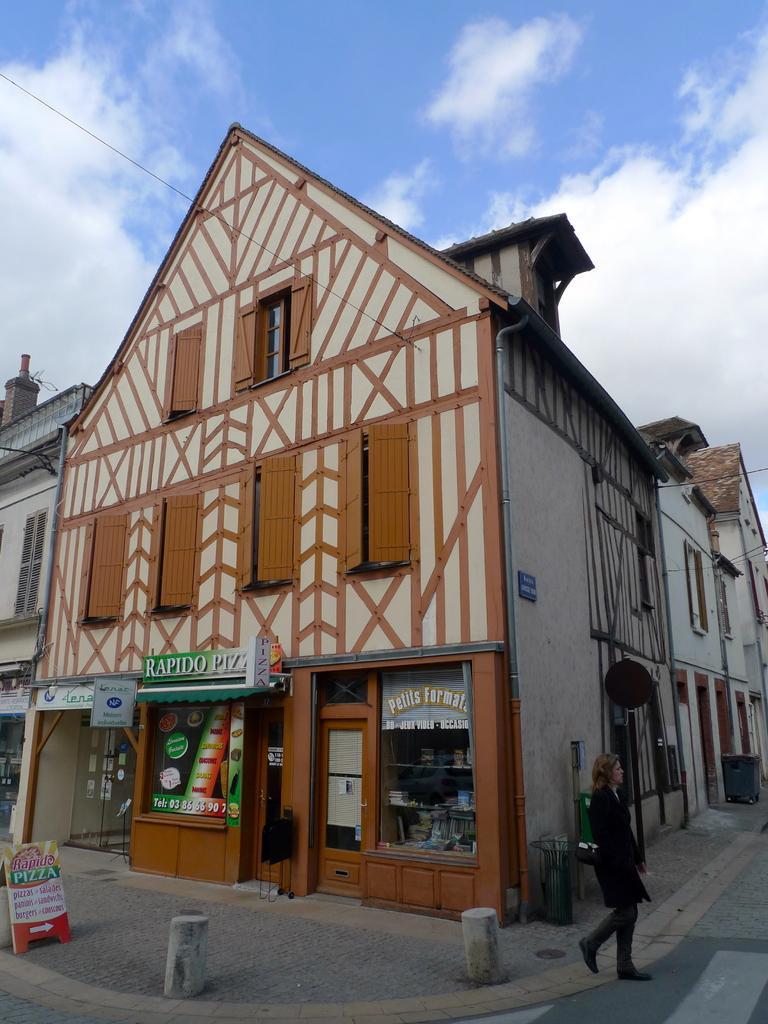Please provide a concise description of this image. In this picture we can observe a building which is in cream and brown color. We can observe a woman walking on the footpath on the right side. In the background there are some buildings We can observe a sky with clouds. 